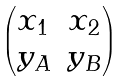Convert formula to latex. <formula><loc_0><loc_0><loc_500><loc_500>\begin{pmatrix} x _ { 1 } & x _ { 2 } \\ y _ { A } & y _ { B } \end{pmatrix}</formula> 